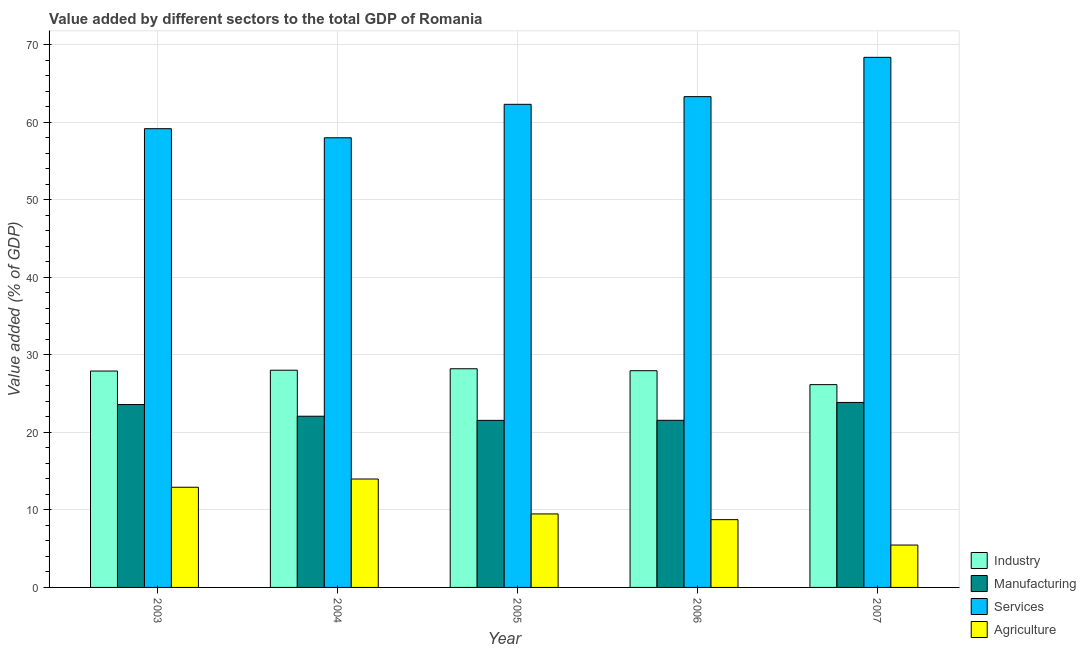How many different coloured bars are there?
Offer a terse response. 4. Are the number of bars on each tick of the X-axis equal?
Provide a succinct answer. Yes. How many bars are there on the 5th tick from the right?
Keep it short and to the point. 4. What is the value added by services sector in 2003?
Offer a terse response. 59.17. Across all years, what is the maximum value added by services sector?
Your answer should be compact. 68.37. Across all years, what is the minimum value added by industrial sector?
Provide a short and direct response. 26.16. In which year was the value added by industrial sector minimum?
Offer a terse response. 2007. What is the total value added by agricultural sector in the graph?
Make the answer very short. 50.6. What is the difference between the value added by services sector in 2004 and that in 2006?
Offer a terse response. -5.31. What is the difference between the value added by manufacturing sector in 2004 and the value added by agricultural sector in 2003?
Offer a terse response. -1.51. What is the average value added by manufacturing sector per year?
Offer a terse response. 22.53. What is the ratio of the value added by services sector in 2006 to that in 2007?
Your answer should be very brief. 0.93. What is the difference between the highest and the second highest value added by agricultural sector?
Your response must be concise. 1.06. What is the difference between the highest and the lowest value added by manufacturing sector?
Give a very brief answer. 2.31. What does the 2nd bar from the left in 2006 represents?
Your answer should be very brief. Manufacturing. What does the 4th bar from the right in 2003 represents?
Offer a very short reply. Industry. Are all the bars in the graph horizontal?
Give a very brief answer. No. How many years are there in the graph?
Provide a short and direct response. 5. What is the difference between two consecutive major ticks on the Y-axis?
Offer a very short reply. 10. Does the graph contain any zero values?
Provide a short and direct response. No. Does the graph contain grids?
Your response must be concise. Yes. How many legend labels are there?
Your response must be concise. 4. How are the legend labels stacked?
Ensure brevity in your answer.  Vertical. What is the title of the graph?
Provide a short and direct response. Value added by different sectors to the total GDP of Romania. Does "UNAIDS" appear as one of the legend labels in the graph?
Make the answer very short. No. What is the label or title of the X-axis?
Offer a very short reply. Year. What is the label or title of the Y-axis?
Provide a short and direct response. Value added (% of GDP). What is the Value added (% of GDP) of Industry in 2003?
Give a very brief answer. 27.91. What is the Value added (% of GDP) of Manufacturing in 2003?
Your answer should be compact. 23.59. What is the Value added (% of GDP) of Services in 2003?
Make the answer very short. 59.17. What is the Value added (% of GDP) of Agriculture in 2003?
Give a very brief answer. 12.92. What is the Value added (% of GDP) in Industry in 2004?
Provide a succinct answer. 28.02. What is the Value added (% of GDP) in Manufacturing in 2004?
Make the answer very short. 22.08. What is the Value added (% of GDP) of Services in 2004?
Your answer should be very brief. 58. What is the Value added (% of GDP) of Agriculture in 2004?
Offer a very short reply. 13.98. What is the Value added (% of GDP) of Industry in 2005?
Your response must be concise. 28.21. What is the Value added (% of GDP) of Manufacturing in 2005?
Ensure brevity in your answer.  21.55. What is the Value added (% of GDP) of Services in 2005?
Offer a terse response. 62.31. What is the Value added (% of GDP) of Agriculture in 2005?
Provide a succinct answer. 9.48. What is the Value added (% of GDP) in Industry in 2006?
Your answer should be compact. 27.95. What is the Value added (% of GDP) of Manufacturing in 2006?
Your answer should be compact. 21.56. What is the Value added (% of GDP) in Services in 2006?
Ensure brevity in your answer.  63.3. What is the Value added (% of GDP) in Agriculture in 2006?
Your answer should be compact. 8.74. What is the Value added (% of GDP) in Industry in 2007?
Provide a succinct answer. 26.16. What is the Value added (% of GDP) of Manufacturing in 2007?
Offer a terse response. 23.86. What is the Value added (% of GDP) of Services in 2007?
Your answer should be compact. 68.37. What is the Value added (% of GDP) in Agriculture in 2007?
Offer a terse response. 5.47. Across all years, what is the maximum Value added (% of GDP) in Industry?
Provide a succinct answer. 28.21. Across all years, what is the maximum Value added (% of GDP) in Manufacturing?
Offer a very short reply. 23.86. Across all years, what is the maximum Value added (% of GDP) in Services?
Offer a very short reply. 68.37. Across all years, what is the maximum Value added (% of GDP) of Agriculture?
Your response must be concise. 13.98. Across all years, what is the minimum Value added (% of GDP) of Industry?
Your response must be concise. 26.16. Across all years, what is the minimum Value added (% of GDP) of Manufacturing?
Give a very brief answer. 21.55. Across all years, what is the minimum Value added (% of GDP) of Services?
Offer a terse response. 58. Across all years, what is the minimum Value added (% of GDP) of Agriculture?
Your answer should be very brief. 5.47. What is the total Value added (% of GDP) in Industry in the graph?
Ensure brevity in your answer.  138.25. What is the total Value added (% of GDP) in Manufacturing in the graph?
Your answer should be very brief. 112.63. What is the total Value added (% of GDP) of Services in the graph?
Offer a terse response. 311.16. What is the total Value added (% of GDP) in Agriculture in the graph?
Your answer should be compact. 50.6. What is the difference between the Value added (% of GDP) of Industry in 2003 and that in 2004?
Provide a succinct answer. -0.11. What is the difference between the Value added (% of GDP) of Manufacturing in 2003 and that in 2004?
Offer a very short reply. 1.51. What is the difference between the Value added (% of GDP) of Services in 2003 and that in 2004?
Make the answer very short. 1.17. What is the difference between the Value added (% of GDP) in Agriculture in 2003 and that in 2004?
Provide a short and direct response. -1.06. What is the difference between the Value added (% of GDP) in Industry in 2003 and that in 2005?
Ensure brevity in your answer.  -0.3. What is the difference between the Value added (% of GDP) in Manufacturing in 2003 and that in 2005?
Your answer should be compact. 2.04. What is the difference between the Value added (% of GDP) in Services in 2003 and that in 2005?
Ensure brevity in your answer.  -3.14. What is the difference between the Value added (% of GDP) of Agriculture in 2003 and that in 2005?
Your response must be concise. 3.44. What is the difference between the Value added (% of GDP) in Industry in 2003 and that in 2006?
Provide a succinct answer. -0.04. What is the difference between the Value added (% of GDP) in Manufacturing in 2003 and that in 2006?
Keep it short and to the point. 2.03. What is the difference between the Value added (% of GDP) in Services in 2003 and that in 2006?
Provide a short and direct response. -4.13. What is the difference between the Value added (% of GDP) of Agriculture in 2003 and that in 2006?
Give a very brief answer. 4.18. What is the difference between the Value added (% of GDP) of Industry in 2003 and that in 2007?
Give a very brief answer. 1.75. What is the difference between the Value added (% of GDP) in Manufacturing in 2003 and that in 2007?
Give a very brief answer. -0.27. What is the difference between the Value added (% of GDP) of Services in 2003 and that in 2007?
Ensure brevity in your answer.  -9.21. What is the difference between the Value added (% of GDP) in Agriculture in 2003 and that in 2007?
Offer a very short reply. 7.45. What is the difference between the Value added (% of GDP) of Industry in 2004 and that in 2005?
Keep it short and to the point. -0.19. What is the difference between the Value added (% of GDP) of Manufacturing in 2004 and that in 2005?
Provide a succinct answer. 0.54. What is the difference between the Value added (% of GDP) in Services in 2004 and that in 2005?
Provide a succinct answer. -4.32. What is the difference between the Value added (% of GDP) in Agriculture in 2004 and that in 2005?
Ensure brevity in your answer.  4.5. What is the difference between the Value added (% of GDP) in Industry in 2004 and that in 2006?
Your answer should be compact. 0.06. What is the difference between the Value added (% of GDP) of Manufacturing in 2004 and that in 2006?
Your answer should be compact. 0.53. What is the difference between the Value added (% of GDP) in Services in 2004 and that in 2006?
Offer a terse response. -5.31. What is the difference between the Value added (% of GDP) of Agriculture in 2004 and that in 2006?
Offer a very short reply. 5.24. What is the difference between the Value added (% of GDP) of Industry in 2004 and that in 2007?
Give a very brief answer. 1.86. What is the difference between the Value added (% of GDP) in Manufacturing in 2004 and that in 2007?
Your answer should be compact. -1.78. What is the difference between the Value added (% of GDP) of Services in 2004 and that in 2007?
Provide a short and direct response. -10.38. What is the difference between the Value added (% of GDP) of Agriculture in 2004 and that in 2007?
Your answer should be very brief. 8.52. What is the difference between the Value added (% of GDP) in Industry in 2005 and that in 2006?
Keep it short and to the point. 0.25. What is the difference between the Value added (% of GDP) of Manufacturing in 2005 and that in 2006?
Make the answer very short. -0.01. What is the difference between the Value added (% of GDP) of Services in 2005 and that in 2006?
Make the answer very short. -0.99. What is the difference between the Value added (% of GDP) of Agriculture in 2005 and that in 2006?
Keep it short and to the point. 0.74. What is the difference between the Value added (% of GDP) in Industry in 2005 and that in 2007?
Make the answer very short. 2.05. What is the difference between the Value added (% of GDP) in Manufacturing in 2005 and that in 2007?
Ensure brevity in your answer.  -2.31. What is the difference between the Value added (% of GDP) in Services in 2005 and that in 2007?
Your response must be concise. -6.06. What is the difference between the Value added (% of GDP) in Agriculture in 2005 and that in 2007?
Provide a short and direct response. 4.01. What is the difference between the Value added (% of GDP) of Industry in 2006 and that in 2007?
Provide a succinct answer. 1.8. What is the difference between the Value added (% of GDP) in Manufacturing in 2006 and that in 2007?
Make the answer very short. -2.3. What is the difference between the Value added (% of GDP) of Services in 2006 and that in 2007?
Provide a succinct answer. -5.07. What is the difference between the Value added (% of GDP) of Agriculture in 2006 and that in 2007?
Your response must be concise. 3.28. What is the difference between the Value added (% of GDP) in Industry in 2003 and the Value added (% of GDP) in Manufacturing in 2004?
Offer a very short reply. 5.83. What is the difference between the Value added (% of GDP) in Industry in 2003 and the Value added (% of GDP) in Services in 2004?
Your response must be concise. -30.09. What is the difference between the Value added (% of GDP) of Industry in 2003 and the Value added (% of GDP) of Agriculture in 2004?
Provide a short and direct response. 13.93. What is the difference between the Value added (% of GDP) in Manufacturing in 2003 and the Value added (% of GDP) in Services in 2004?
Provide a succinct answer. -34.41. What is the difference between the Value added (% of GDP) in Manufacturing in 2003 and the Value added (% of GDP) in Agriculture in 2004?
Keep it short and to the point. 9.6. What is the difference between the Value added (% of GDP) in Services in 2003 and the Value added (% of GDP) in Agriculture in 2004?
Your response must be concise. 45.18. What is the difference between the Value added (% of GDP) in Industry in 2003 and the Value added (% of GDP) in Manufacturing in 2005?
Provide a short and direct response. 6.36. What is the difference between the Value added (% of GDP) of Industry in 2003 and the Value added (% of GDP) of Services in 2005?
Keep it short and to the point. -34.4. What is the difference between the Value added (% of GDP) in Industry in 2003 and the Value added (% of GDP) in Agriculture in 2005?
Offer a terse response. 18.43. What is the difference between the Value added (% of GDP) in Manufacturing in 2003 and the Value added (% of GDP) in Services in 2005?
Your answer should be very brief. -38.73. What is the difference between the Value added (% of GDP) in Manufacturing in 2003 and the Value added (% of GDP) in Agriculture in 2005?
Ensure brevity in your answer.  14.11. What is the difference between the Value added (% of GDP) of Services in 2003 and the Value added (% of GDP) of Agriculture in 2005?
Your response must be concise. 49.69. What is the difference between the Value added (% of GDP) of Industry in 2003 and the Value added (% of GDP) of Manufacturing in 2006?
Give a very brief answer. 6.35. What is the difference between the Value added (% of GDP) of Industry in 2003 and the Value added (% of GDP) of Services in 2006?
Your answer should be compact. -35.39. What is the difference between the Value added (% of GDP) in Industry in 2003 and the Value added (% of GDP) in Agriculture in 2006?
Your answer should be very brief. 19.17. What is the difference between the Value added (% of GDP) in Manufacturing in 2003 and the Value added (% of GDP) in Services in 2006?
Provide a short and direct response. -39.72. What is the difference between the Value added (% of GDP) in Manufacturing in 2003 and the Value added (% of GDP) in Agriculture in 2006?
Provide a succinct answer. 14.85. What is the difference between the Value added (% of GDP) in Services in 2003 and the Value added (% of GDP) in Agriculture in 2006?
Offer a very short reply. 50.43. What is the difference between the Value added (% of GDP) in Industry in 2003 and the Value added (% of GDP) in Manufacturing in 2007?
Give a very brief answer. 4.05. What is the difference between the Value added (% of GDP) in Industry in 2003 and the Value added (% of GDP) in Services in 2007?
Your response must be concise. -40.46. What is the difference between the Value added (% of GDP) in Industry in 2003 and the Value added (% of GDP) in Agriculture in 2007?
Provide a short and direct response. 22.44. What is the difference between the Value added (% of GDP) in Manufacturing in 2003 and the Value added (% of GDP) in Services in 2007?
Ensure brevity in your answer.  -44.79. What is the difference between the Value added (% of GDP) in Manufacturing in 2003 and the Value added (% of GDP) in Agriculture in 2007?
Your answer should be very brief. 18.12. What is the difference between the Value added (% of GDP) in Services in 2003 and the Value added (% of GDP) in Agriculture in 2007?
Offer a very short reply. 53.7. What is the difference between the Value added (% of GDP) of Industry in 2004 and the Value added (% of GDP) of Manufacturing in 2005?
Your answer should be very brief. 6.47. What is the difference between the Value added (% of GDP) of Industry in 2004 and the Value added (% of GDP) of Services in 2005?
Give a very brief answer. -34.3. What is the difference between the Value added (% of GDP) in Industry in 2004 and the Value added (% of GDP) in Agriculture in 2005?
Keep it short and to the point. 18.54. What is the difference between the Value added (% of GDP) of Manufacturing in 2004 and the Value added (% of GDP) of Services in 2005?
Provide a short and direct response. -40.23. What is the difference between the Value added (% of GDP) of Manufacturing in 2004 and the Value added (% of GDP) of Agriculture in 2005?
Provide a succinct answer. 12.6. What is the difference between the Value added (% of GDP) of Services in 2004 and the Value added (% of GDP) of Agriculture in 2005?
Your answer should be compact. 48.52. What is the difference between the Value added (% of GDP) of Industry in 2004 and the Value added (% of GDP) of Manufacturing in 2006?
Your answer should be very brief. 6.46. What is the difference between the Value added (% of GDP) of Industry in 2004 and the Value added (% of GDP) of Services in 2006?
Keep it short and to the point. -35.29. What is the difference between the Value added (% of GDP) of Industry in 2004 and the Value added (% of GDP) of Agriculture in 2006?
Give a very brief answer. 19.28. What is the difference between the Value added (% of GDP) in Manufacturing in 2004 and the Value added (% of GDP) in Services in 2006?
Provide a succinct answer. -41.22. What is the difference between the Value added (% of GDP) of Manufacturing in 2004 and the Value added (% of GDP) of Agriculture in 2006?
Offer a very short reply. 13.34. What is the difference between the Value added (% of GDP) of Services in 2004 and the Value added (% of GDP) of Agriculture in 2006?
Provide a short and direct response. 49.26. What is the difference between the Value added (% of GDP) of Industry in 2004 and the Value added (% of GDP) of Manufacturing in 2007?
Make the answer very short. 4.16. What is the difference between the Value added (% of GDP) of Industry in 2004 and the Value added (% of GDP) of Services in 2007?
Give a very brief answer. -40.36. What is the difference between the Value added (% of GDP) of Industry in 2004 and the Value added (% of GDP) of Agriculture in 2007?
Provide a short and direct response. 22.55. What is the difference between the Value added (% of GDP) in Manufacturing in 2004 and the Value added (% of GDP) in Services in 2007?
Your response must be concise. -46.29. What is the difference between the Value added (% of GDP) in Manufacturing in 2004 and the Value added (% of GDP) in Agriculture in 2007?
Your answer should be compact. 16.62. What is the difference between the Value added (% of GDP) of Services in 2004 and the Value added (% of GDP) of Agriculture in 2007?
Ensure brevity in your answer.  52.53. What is the difference between the Value added (% of GDP) in Industry in 2005 and the Value added (% of GDP) in Manufacturing in 2006?
Your response must be concise. 6.65. What is the difference between the Value added (% of GDP) of Industry in 2005 and the Value added (% of GDP) of Services in 2006?
Make the answer very short. -35.1. What is the difference between the Value added (% of GDP) of Industry in 2005 and the Value added (% of GDP) of Agriculture in 2006?
Ensure brevity in your answer.  19.46. What is the difference between the Value added (% of GDP) in Manufacturing in 2005 and the Value added (% of GDP) in Services in 2006?
Ensure brevity in your answer.  -41.76. What is the difference between the Value added (% of GDP) of Manufacturing in 2005 and the Value added (% of GDP) of Agriculture in 2006?
Keep it short and to the point. 12.8. What is the difference between the Value added (% of GDP) in Services in 2005 and the Value added (% of GDP) in Agriculture in 2006?
Provide a succinct answer. 53.57. What is the difference between the Value added (% of GDP) in Industry in 2005 and the Value added (% of GDP) in Manufacturing in 2007?
Provide a succinct answer. 4.35. What is the difference between the Value added (% of GDP) of Industry in 2005 and the Value added (% of GDP) of Services in 2007?
Your response must be concise. -40.17. What is the difference between the Value added (% of GDP) in Industry in 2005 and the Value added (% of GDP) in Agriculture in 2007?
Keep it short and to the point. 22.74. What is the difference between the Value added (% of GDP) in Manufacturing in 2005 and the Value added (% of GDP) in Services in 2007?
Keep it short and to the point. -46.83. What is the difference between the Value added (% of GDP) of Manufacturing in 2005 and the Value added (% of GDP) of Agriculture in 2007?
Your response must be concise. 16.08. What is the difference between the Value added (% of GDP) in Services in 2005 and the Value added (% of GDP) in Agriculture in 2007?
Your answer should be very brief. 56.85. What is the difference between the Value added (% of GDP) of Industry in 2006 and the Value added (% of GDP) of Manufacturing in 2007?
Offer a terse response. 4.09. What is the difference between the Value added (% of GDP) of Industry in 2006 and the Value added (% of GDP) of Services in 2007?
Your answer should be very brief. -40.42. What is the difference between the Value added (% of GDP) in Industry in 2006 and the Value added (% of GDP) in Agriculture in 2007?
Make the answer very short. 22.49. What is the difference between the Value added (% of GDP) in Manufacturing in 2006 and the Value added (% of GDP) in Services in 2007?
Your answer should be compact. -46.82. What is the difference between the Value added (% of GDP) in Manufacturing in 2006 and the Value added (% of GDP) in Agriculture in 2007?
Provide a short and direct response. 16.09. What is the difference between the Value added (% of GDP) of Services in 2006 and the Value added (% of GDP) of Agriculture in 2007?
Keep it short and to the point. 57.84. What is the average Value added (% of GDP) in Industry per year?
Offer a terse response. 27.65. What is the average Value added (% of GDP) in Manufacturing per year?
Offer a very short reply. 22.53. What is the average Value added (% of GDP) of Services per year?
Offer a terse response. 62.23. What is the average Value added (% of GDP) of Agriculture per year?
Your response must be concise. 10.12. In the year 2003, what is the difference between the Value added (% of GDP) of Industry and Value added (% of GDP) of Manufacturing?
Offer a very short reply. 4.32. In the year 2003, what is the difference between the Value added (% of GDP) in Industry and Value added (% of GDP) in Services?
Ensure brevity in your answer.  -31.26. In the year 2003, what is the difference between the Value added (% of GDP) of Industry and Value added (% of GDP) of Agriculture?
Provide a succinct answer. 14.99. In the year 2003, what is the difference between the Value added (% of GDP) of Manufacturing and Value added (% of GDP) of Services?
Your answer should be compact. -35.58. In the year 2003, what is the difference between the Value added (% of GDP) in Manufacturing and Value added (% of GDP) in Agriculture?
Provide a short and direct response. 10.67. In the year 2003, what is the difference between the Value added (% of GDP) in Services and Value added (% of GDP) in Agriculture?
Provide a short and direct response. 46.25. In the year 2004, what is the difference between the Value added (% of GDP) in Industry and Value added (% of GDP) in Manufacturing?
Give a very brief answer. 5.93. In the year 2004, what is the difference between the Value added (% of GDP) in Industry and Value added (% of GDP) in Services?
Keep it short and to the point. -29.98. In the year 2004, what is the difference between the Value added (% of GDP) of Industry and Value added (% of GDP) of Agriculture?
Make the answer very short. 14.03. In the year 2004, what is the difference between the Value added (% of GDP) of Manufacturing and Value added (% of GDP) of Services?
Your response must be concise. -35.92. In the year 2004, what is the difference between the Value added (% of GDP) of Manufacturing and Value added (% of GDP) of Agriculture?
Provide a short and direct response. 8.1. In the year 2004, what is the difference between the Value added (% of GDP) of Services and Value added (% of GDP) of Agriculture?
Keep it short and to the point. 44.01. In the year 2005, what is the difference between the Value added (% of GDP) in Industry and Value added (% of GDP) in Manufacturing?
Make the answer very short. 6.66. In the year 2005, what is the difference between the Value added (% of GDP) in Industry and Value added (% of GDP) in Services?
Your answer should be compact. -34.11. In the year 2005, what is the difference between the Value added (% of GDP) of Industry and Value added (% of GDP) of Agriculture?
Offer a very short reply. 18.72. In the year 2005, what is the difference between the Value added (% of GDP) of Manufacturing and Value added (% of GDP) of Services?
Provide a short and direct response. -40.77. In the year 2005, what is the difference between the Value added (% of GDP) in Manufacturing and Value added (% of GDP) in Agriculture?
Provide a short and direct response. 12.07. In the year 2005, what is the difference between the Value added (% of GDP) of Services and Value added (% of GDP) of Agriculture?
Your response must be concise. 52.83. In the year 2006, what is the difference between the Value added (% of GDP) in Industry and Value added (% of GDP) in Manufacturing?
Your answer should be compact. 6.4. In the year 2006, what is the difference between the Value added (% of GDP) in Industry and Value added (% of GDP) in Services?
Keep it short and to the point. -35.35. In the year 2006, what is the difference between the Value added (% of GDP) in Industry and Value added (% of GDP) in Agriculture?
Make the answer very short. 19.21. In the year 2006, what is the difference between the Value added (% of GDP) of Manufacturing and Value added (% of GDP) of Services?
Give a very brief answer. -41.75. In the year 2006, what is the difference between the Value added (% of GDP) in Manufacturing and Value added (% of GDP) in Agriculture?
Your answer should be very brief. 12.81. In the year 2006, what is the difference between the Value added (% of GDP) in Services and Value added (% of GDP) in Agriculture?
Provide a succinct answer. 54.56. In the year 2007, what is the difference between the Value added (% of GDP) of Industry and Value added (% of GDP) of Manufacturing?
Ensure brevity in your answer.  2.3. In the year 2007, what is the difference between the Value added (% of GDP) in Industry and Value added (% of GDP) in Services?
Ensure brevity in your answer.  -42.22. In the year 2007, what is the difference between the Value added (% of GDP) of Industry and Value added (% of GDP) of Agriculture?
Provide a short and direct response. 20.69. In the year 2007, what is the difference between the Value added (% of GDP) of Manufacturing and Value added (% of GDP) of Services?
Give a very brief answer. -44.52. In the year 2007, what is the difference between the Value added (% of GDP) of Manufacturing and Value added (% of GDP) of Agriculture?
Your answer should be very brief. 18.39. In the year 2007, what is the difference between the Value added (% of GDP) in Services and Value added (% of GDP) in Agriculture?
Offer a terse response. 62.91. What is the ratio of the Value added (% of GDP) of Industry in 2003 to that in 2004?
Offer a terse response. 1. What is the ratio of the Value added (% of GDP) in Manufacturing in 2003 to that in 2004?
Give a very brief answer. 1.07. What is the ratio of the Value added (% of GDP) in Services in 2003 to that in 2004?
Offer a terse response. 1.02. What is the ratio of the Value added (% of GDP) in Agriculture in 2003 to that in 2004?
Your answer should be compact. 0.92. What is the ratio of the Value added (% of GDP) in Industry in 2003 to that in 2005?
Ensure brevity in your answer.  0.99. What is the ratio of the Value added (% of GDP) of Manufacturing in 2003 to that in 2005?
Keep it short and to the point. 1.09. What is the ratio of the Value added (% of GDP) of Services in 2003 to that in 2005?
Your response must be concise. 0.95. What is the ratio of the Value added (% of GDP) of Agriculture in 2003 to that in 2005?
Provide a succinct answer. 1.36. What is the ratio of the Value added (% of GDP) of Industry in 2003 to that in 2006?
Ensure brevity in your answer.  1. What is the ratio of the Value added (% of GDP) of Manufacturing in 2003 to that in 2006?
Offer a terse response. 1.09. What is the ratio of the Value added (% of GDP) of Services in 2003 to that in 2006?
Give a very brief answer. 0.93. What is the ratio of the Value added (% of GDP) of Agriculture in 2003 to that in 2006?
Your response must be concise. 1.48. What is the ratio of the Value added (% of GDP) of Industry in 2003 to that in 2007?
Make the answer very short. 1.07. What is the ratio of the Value added (% of GDP) of Services in 2003 to that in 2007?
Provide a succinct answer. 0.87. What is the ratio of the Value added (% of GDP) of Agriculture in 2003 to that in 2007?
Keep it short and to the point. 2.36. What is the ratio of the Value added (% of GDP) of Industry in 2004 to that in 2005?
Keep it short and to the point. 0.99. What is the ratio of the Value added (% of GDP) of Manufacturing in 2004 to that in 2005?
Make the answer very short. 1.02. What is the ratio of the Value added (% of GDP) in Services in 2004 to that in 2005?
Provide a succinct answer. 0.93. What is the ratio of the Value added (% of GDP) of Agriculture in 2004 to that in 2005?
Ensure brevity in your answer.  1.48. What is the ratio of the Value added (% of GDP) in Manufacturing in 2004 to that in 2006?
Your response must be concise. 1.02. What is the ratio of the Value added (% of GDP) of Services in 2004 to that in 2006?
Offer a terse response. 0.92. What is the ratio of the Value added (% of GDP) of Agriculture in 2004 to that in 2006?
Your response must be concise. 1.6. What is the ratio of the Value added (% of GDP) in Industry in 2004 to that in 2007?
Make the answer very short. 1.07. What is the ratio of the Value added (% of GDP) of Manufacturing in 2004 to that in 2007?
Provide a short and direct response. 0.93. What is the ratio of the Value added (% of GDP) of Services in 2004 to that in 2007?
Provide a succinct answer. 0.85. What is the ratio of the Value added (% of GDP) in Agriculture in 2004 to that in 2007?
Your answer should be compact. 2.56. What is the ratio of the Value added (% of GDP) of Services in 2005 to that in 2006?
Ensure brevity in your answer.  0.98. What is the ratio of the Value added (% of GDP) of Agriculture in 2005 to that in 2006?
Offer a very short reply. 1.08. What is the ratio of the Value added (% of GDP) in Industry in 2005 to that in 2007?
Your answer should be very brief. 1.08. What is the ratio of the Value added (% of GDP) of Manufacturing in 2005 to that in 2007?
Your response must be concise. 0.9. What is the ratio of the Value added (% of GDP) of Services in 2005 to that in 2007?
Ensure brevity in your answer.  0.91. What is the ratio of the Value added (% of GDP) of Agriculture in 2005 to that in 2007?
Offer a terse response. 1.73. What is the ratio of the Value added (% of GDP) in Industry in 2006 to that in 2007?
Provide a succinct answer. 1.07. What is the ratio of the Value added (% of GDP) in Manufacturing in 2006 to that in 2007?
Your answer should be compact. 0.9. What is the ratio of the Value added (% of GDP) in Services in 2006 to that in 2007?
Make the answer very short. 0.93. What is the ratio of the Value added (% of GDP) of Agriculture in 2006 to that in 2007?
Make the answer very short. 1.6. What is the difference between the highest and the second highest Value added (% of GDP) in Industry?
Ensure brevity in your answer.  0.19. What is the difference between the highest and the second highest Value added (% of GDP) in Manufacturing?
Keep it short and to the point. 0.27. What is the difference between the highest and the second highest Value added (% of GDP) in Services?
Make the answer very short. 5.07. What is the difference between the highest and the second highest Value added (% of GDP) of Agriculture?
Your answer should be compact. 1.06. What is the difference between the highest and the lowest Value added (% of GDP) of Industry?
Offer a very short reply. 2.05. What is the difference between the highest and the lowest Value added (% of GDP) of Manufacturing?
Make the answer very short. 2.31. What is the difference between the highest and the lowest Value added (% of GDP) in Services?
Make the answer very short. 10.38. What is the difference between the highest and the lowest Value added (% of GDP) of Agriculture?
Give a very brief answer. 8.52. 